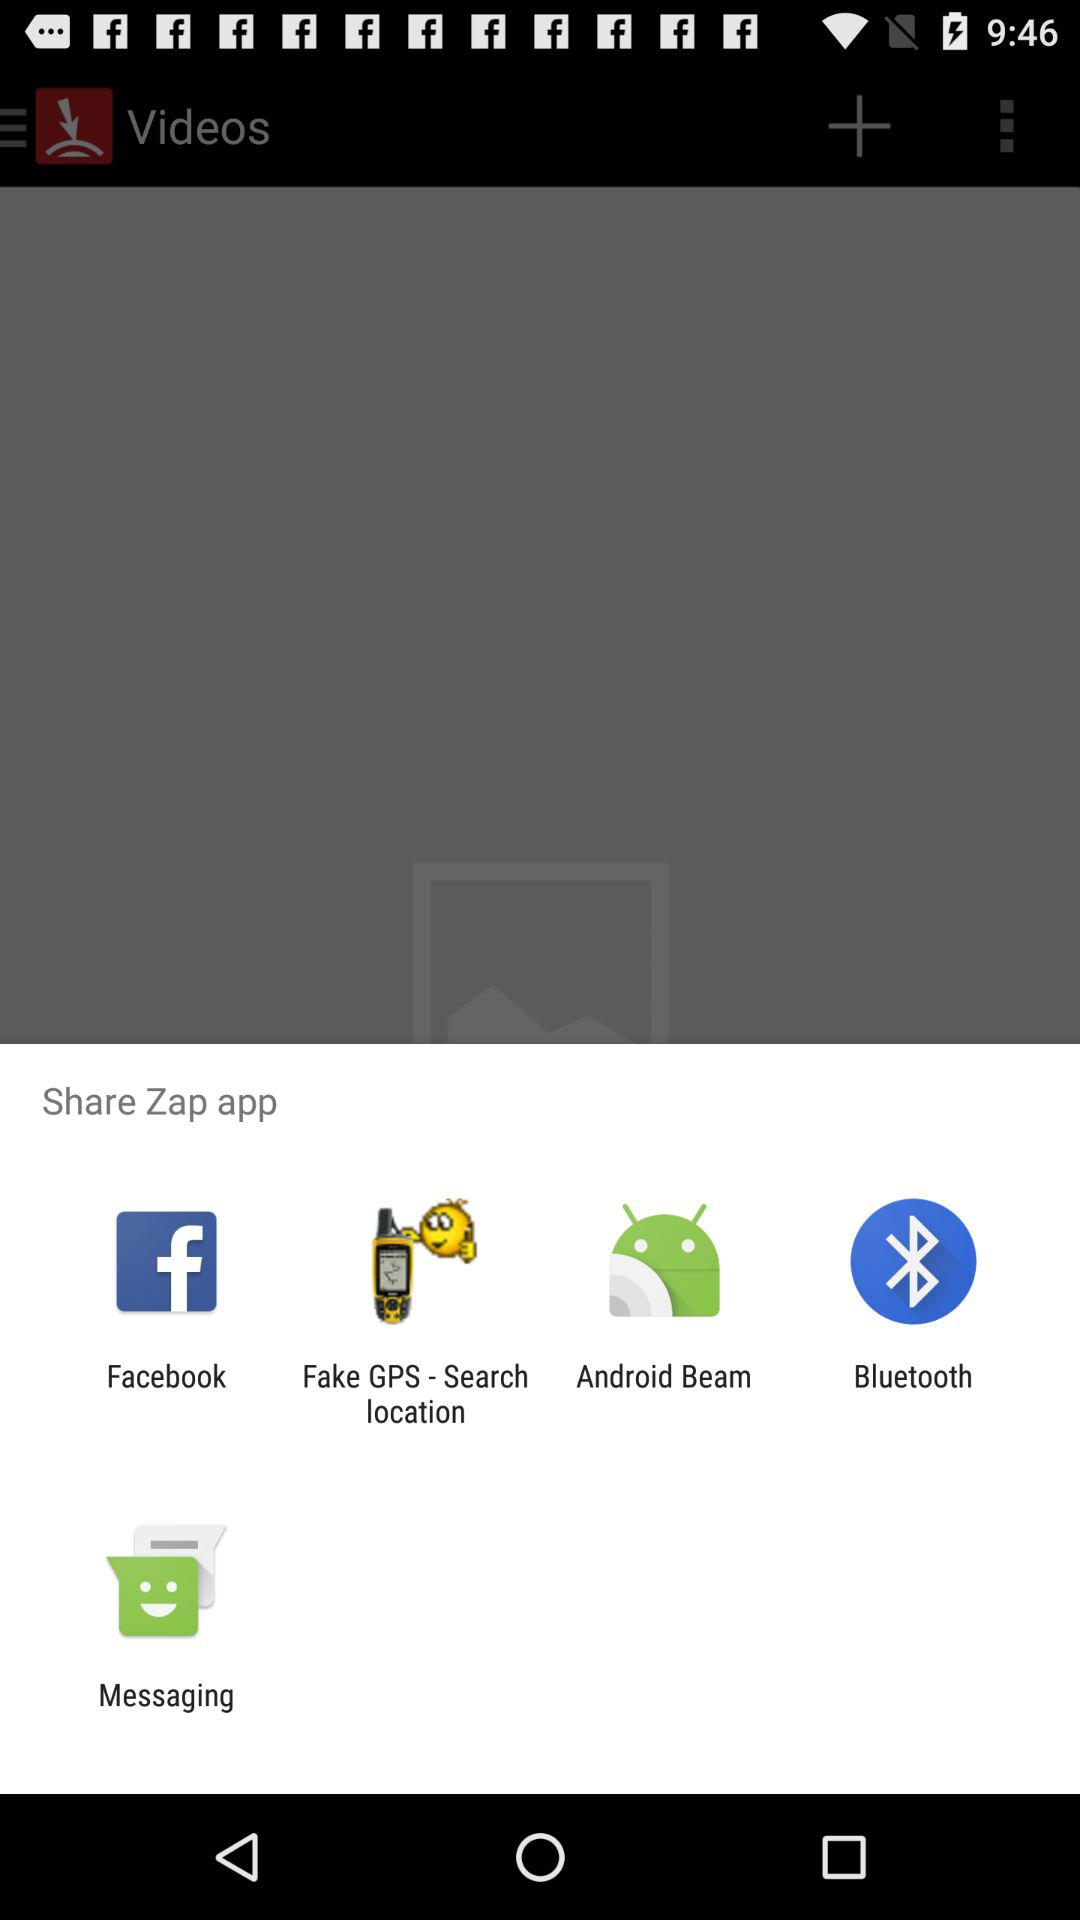Which app can we share with? You can share with "Facebook", "Fake GPS - Search location", "Android Beam", "Bluetooth" and "Messaging". 